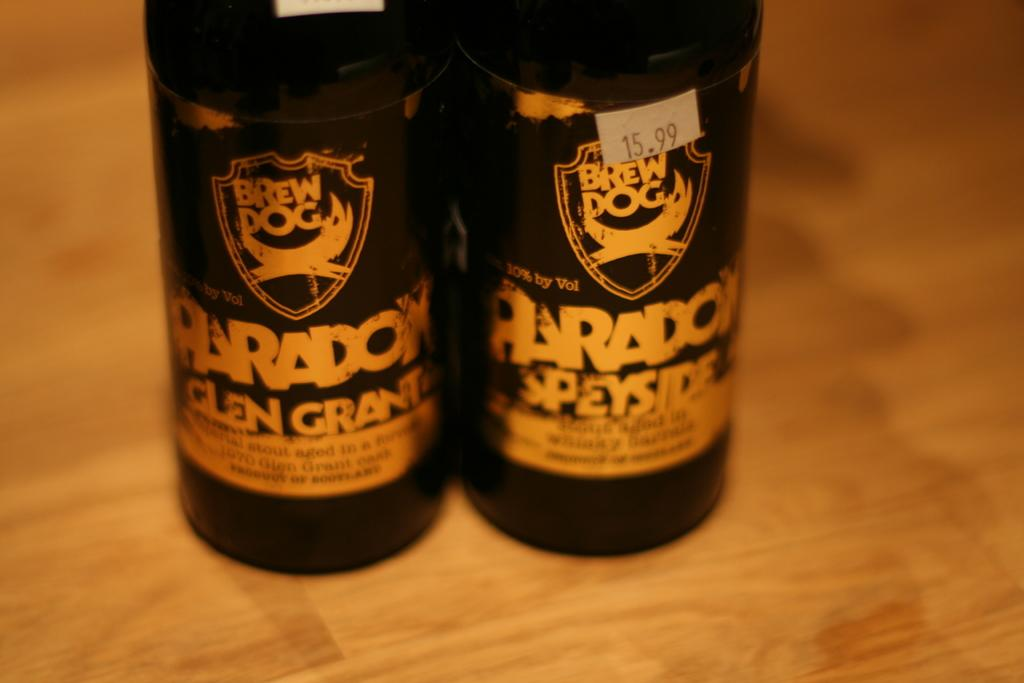<image>
Write a terse but informative summary of the picture. A couple of Brew Dog bottles have Paradox on the label. 